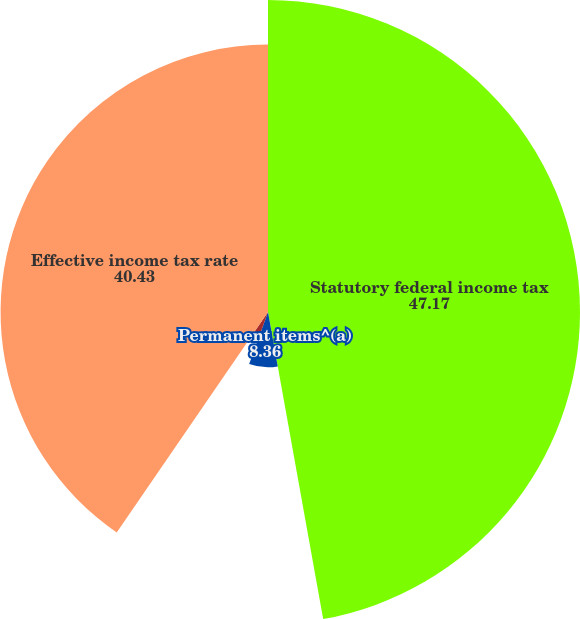<chart> <loc_0><loc_0><loc_500><loc_500><pie_chart><fcel>Statutory federal income tax<fcel>Permanent items^(a)<fcel>State tax<fcel>Effective income tax rate<nl><fcel>47.17%<fcel>8.36%<fcel>4.04%<fcel>40.43%<nl></chart> 